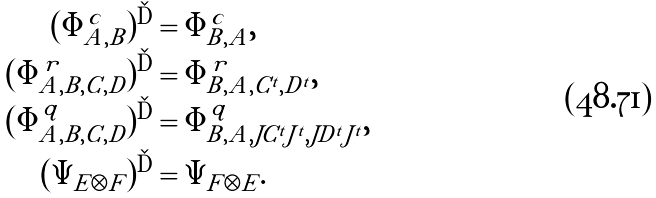Convert formula to latex. <formula><loc_0><loc_0><loc_500><loc_500>( \Phi _ { A , B } ^ { c } ) ^ { \dag } & = \Phi _ { B , A } ^ { c } , \\ ( \Phi _ { A , B , C , D } ^ { r } ) ^ { \dag } & = \Phi _ { B , A , C ^ { t } , D ^ { t } } ^ { r } , \\ ( \Phi _ { A , B , C , D } ^ { q } ) ^ { \dag } & = \Phi _ { B , A , J C ^ { t } J ^ { t } , J D ^ { t } J ^ { t } } ^ { q } , \\ ( \Psi _ { E \otimes F } ) ^ { \dag } & = \Psi _ { F \otimes E } .</formula> 